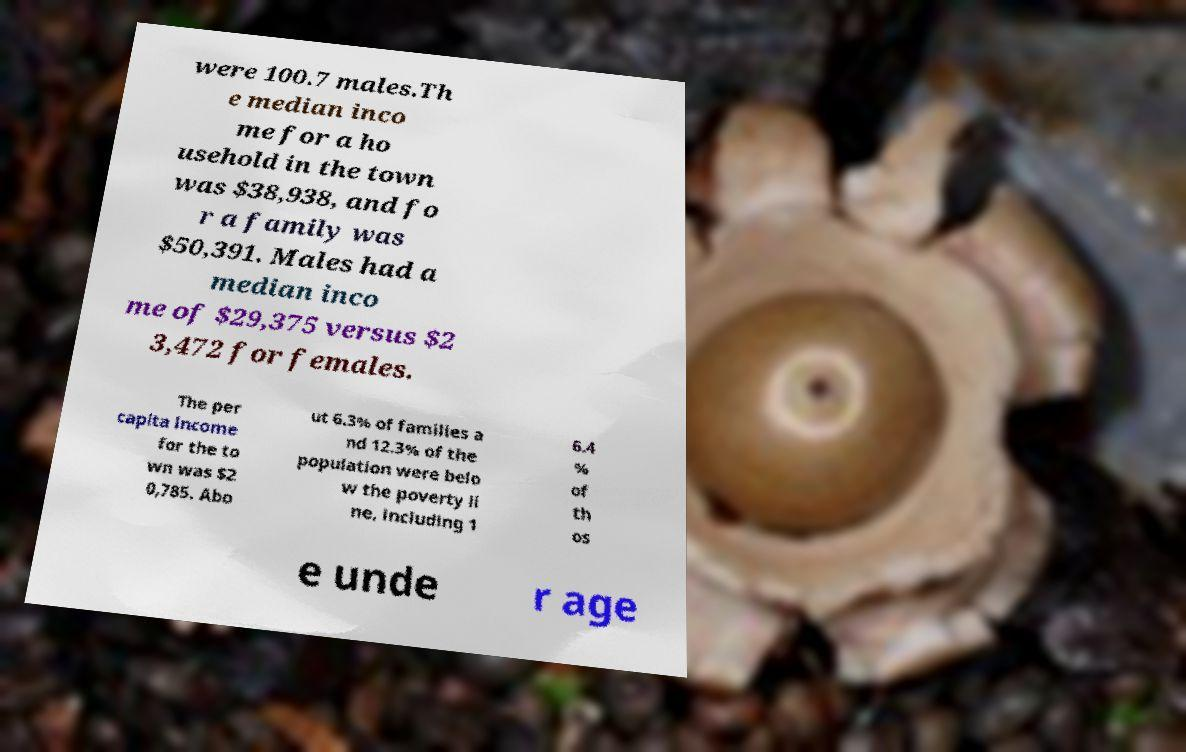Can you read and provide the text displayed in the image?This photo seems to have some interesting text. Can you extract and type it out for me? were 100.7 males.Th e median inco me for a ho usehold in the town was $38,938, and fo r a family was $50,391. Males had a median inco me of $29,375 versus $2 3,472 for females. The per capita income for the to wn was $2 0,785. Abo ut 6.3% of families a nd 12.3% of the population were belo w the poverty li ne, including 1 6.4 % of th os e unde r age 